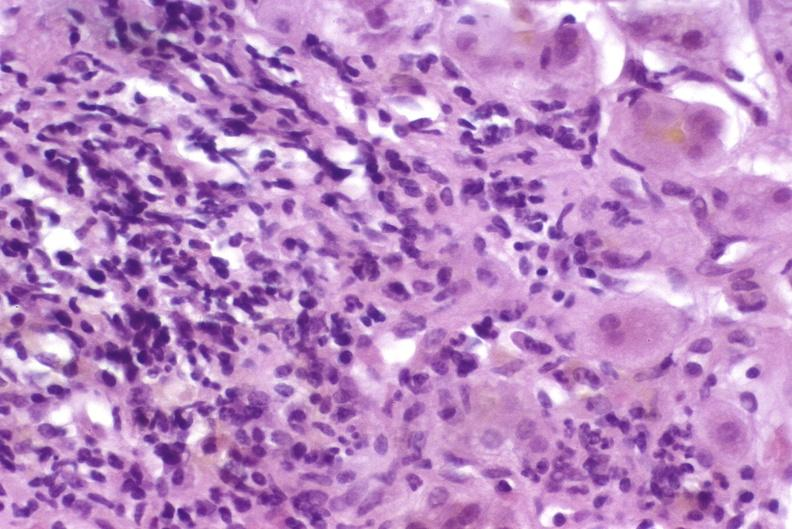s hepatobiliary present?
Answer the question using a single word or phrase. Yes 